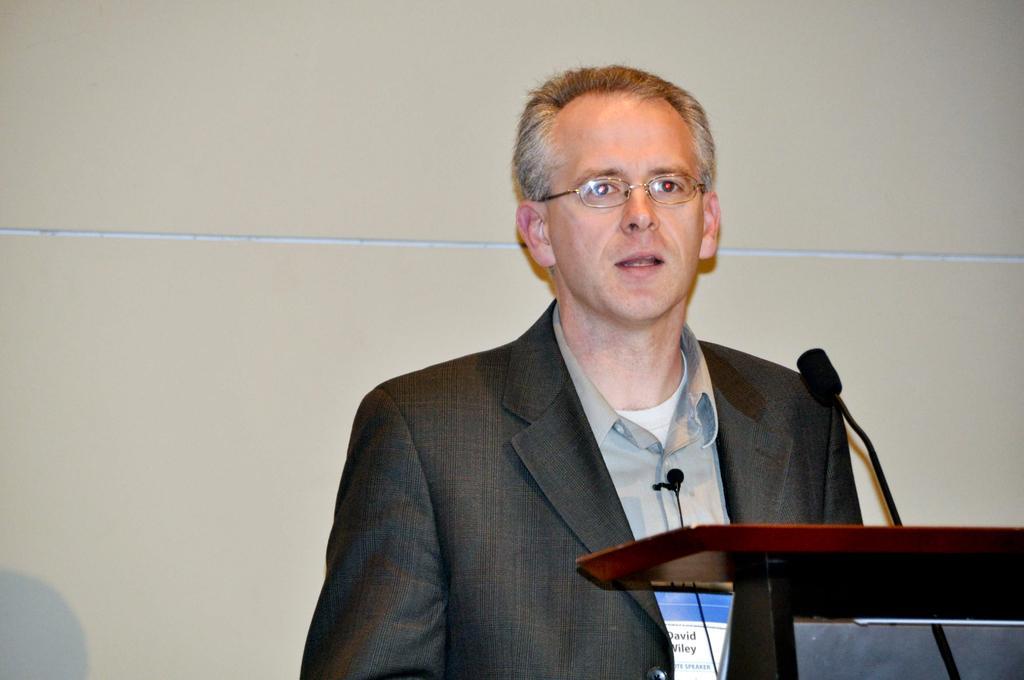Please provide a concise description of this image. In this picture there is a man standing and talking. In the foreground there is a microphone on the podium. At the back it looks like a wall. 